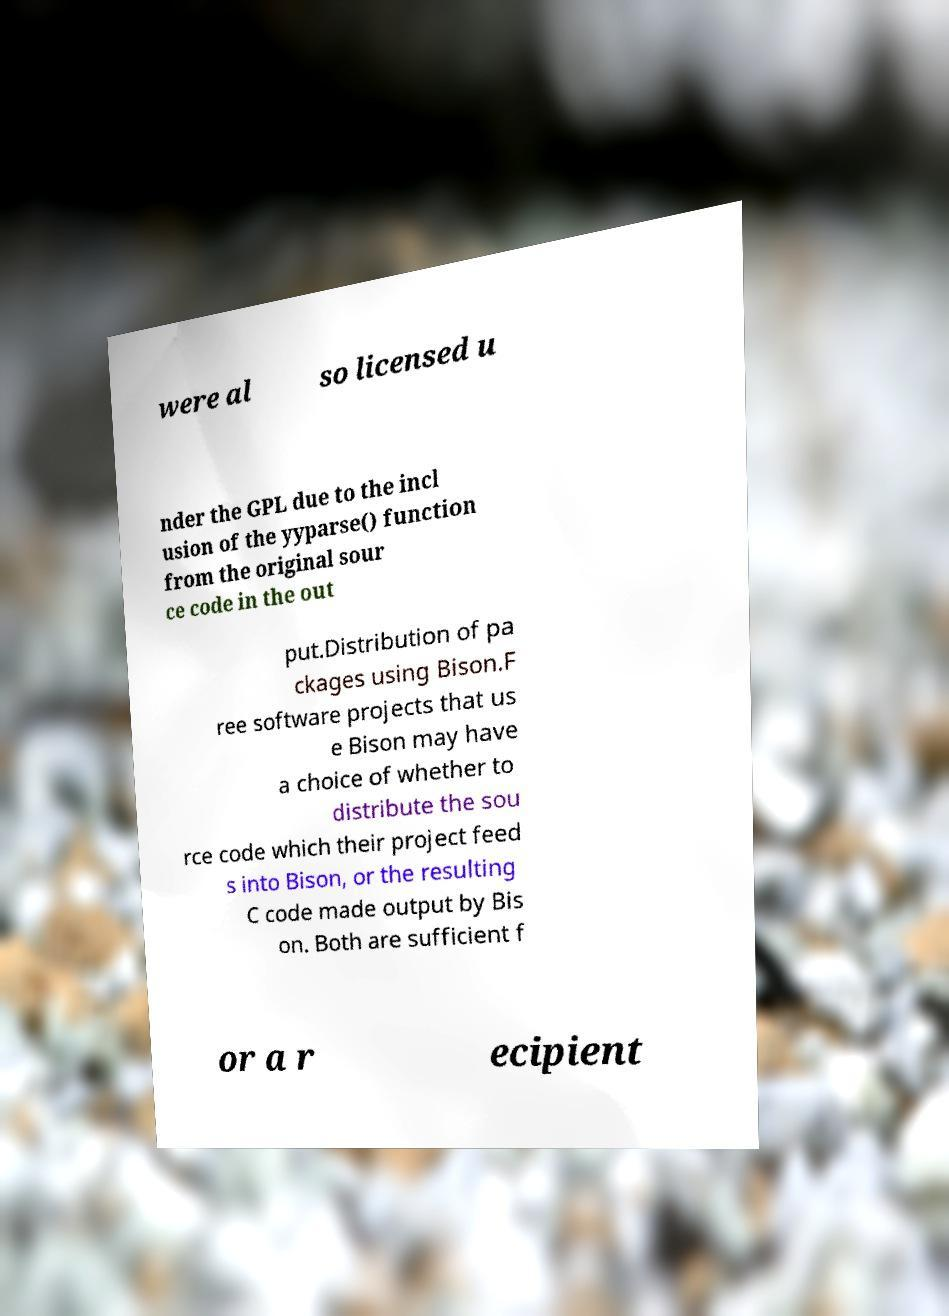Please identify and transcribe the text found in this image. were al so licensed u nder the GPL due to the incl usion of the yyparse() function from the original sour ce code in the out put.Distribution of pa ckages using Bison.F ree software projects that us e Bison may have a choice of whether to distribute the sou rce code which their project feed s into Bison, or the resulting C code made output by Bis on. Both are sufficient f or a r ecipient 